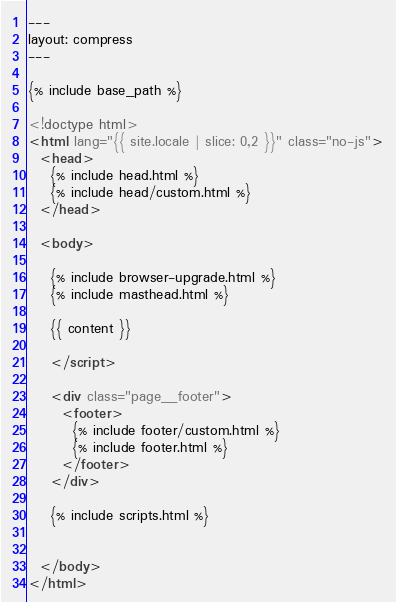<code> <loc_0><loc_0><loc_500><loc_500><_HTML_>---
layout: compress
---

{% include base_path %}

<!doctype html>
<html lang="{{ site.locale | slice: 0,2 }}" class="no-js">
  <head>
    {% include head.html %}
    {% include head/custom.html %}
  </head>

  <body>

    {% include browser-upgrade.html %}
    {% include masthead.html %}

    {{ content }}

    </script>

    <div class="page__footer">
      <footer>
        {% include footer/custom.html %}
        {% include footer.html %}
      </footer>
    </div>

    {% include scripts.html %}
    

  </body>
</html>
</code> 